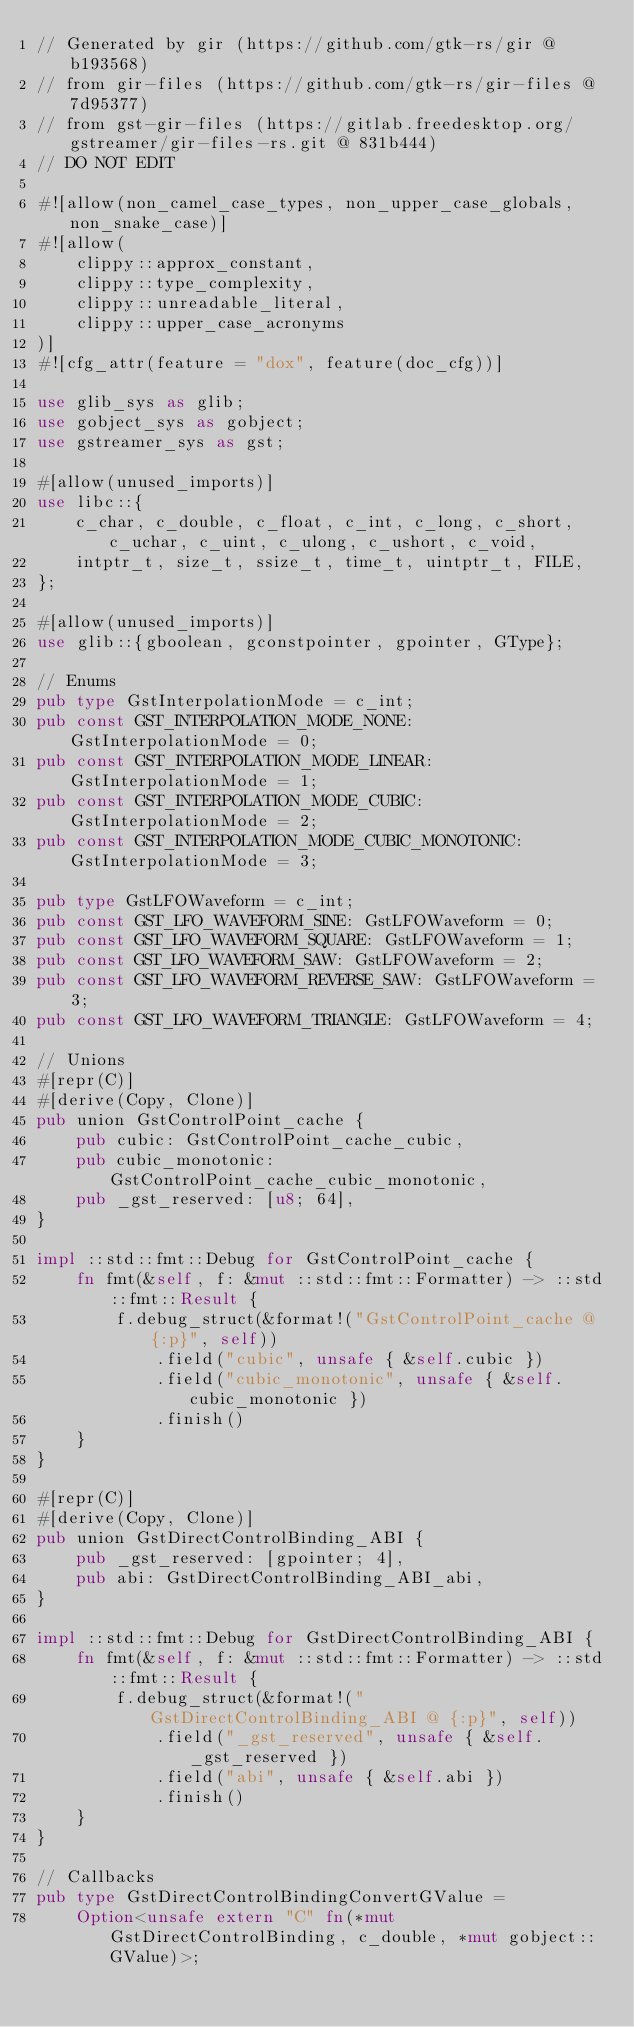<code> <loc_0><loc_0><loc_500><loc_500><_Rust_>// Generated by gir (https://github.com/gtk-rs/gir @ b193568)
// from gir-files (https://github.com/gtk-rs/gir-files @ 7d95377)
// from gst-gir-files (https://gitlab.freedesktop.org/gstreamer/gir-files-rs.git @ 831b444)
// DO NOT EDIT

#![allow(non_camel_case_types, non_upper_case_globals, non_snake_case)]
#![allow(
    clippy::approx_constant,
    clippy::type_complexity,
    clippy::unreadable_literal,
    clippy::upper_case_acronyms
)]
#![cfg_attr(feature = "dox", feature(doc_cfg))]

use glib_sys as glib;
use gobject_sys as gobject;
use gstreamer_sys as gst;

#[allow(unused_imports)]
use libc::{
    c_char, c_double, c_float, c_int, c_long, c_short, c_uchar, c_uint, c_ulong, c_ushort, c_void,
    intptr_t, size_t, ssize_t, time_t, uintptr_t, FILE,
};

#[allow(unused_imports)]
use glib::{gboolean, gconstpointer, gpointer, GType};

// Enums
pub type GstInterpolationMode = c_int;
pub const GST_INTERPOLATION_MODE_NONE: GstInterpolationMode = 0;
pub const GST_INTERPOLATION_MODE_LINEAR: GstInterpolationMode = 1;
pub const GST_INTERPOLATION_MODE_CUBIC: GstInterpolationMode = 2;
pub const GST_INTERPOLATION_MODE_CUBIC_MONOTONIC: GstInterpolationMode = 3;

pub type GstLFOWaveform = c_int;
pub const GST_LFO_WAVEFORM_SINE: GstLFOWaveform = 0;
pub const GST_LFO_WAVEFORM_SQUARE: GstLFOWaveform = 1;
pub const GST_LFO_WAVEFORM_SAW: GstLFOWaveform = 2;
pub const GST_LFO_WAVEFORM_REVERSE_SAW: GstLFOWaveform = 3;
pub const GST_LFO_WAVEFORM_TRIANGLE: GstLFOWaveform = 4;

// Unions
#[repr(C)]
#[derive(Copy, Clone)]
pub union GstControlPoint_cache {
    pub cubic: GstControlPoint_cache_cubic,
    pub cubic_monotonic: GstControlPoint_cache_cubic_monotonic,
    pub _gst_reserved: [u8; 64],
}

impl ::std::fmt::Debug for GstControlPoint_cache {
    fn fmt(&self, f: &mut ::std::fmt::Formatter) -> ::std::fmt::Result {
        f.debug_struct(&format!("GstControlPoint_cache @ {:p}", self))
            .field("cubic", unsafe { &self.cubic })
            .field("cubic_monotonic", unsafe { &self.cubic_monotonic })
            .finish()
    }
}

#[repr(C)]
#[derive(Copy, Clone)]
pub union GstDirectControlBinding_ABI {
    pub _gst_reserved: [gpointer; 4],
    pub abi: GstDirectControlBinding_ABI_abi,
}

impl ::std::fmt::Debug for GstDirectControlBinding_ABI {
    fn fmt(&self, f: &mut ::std::fmt::Formatter) -> ::std::fmt::Result {
        f.debug_struct(&format!("GstDirectControlBinding_ABI @ {:p}", self))
            .field("_gst_reserved", unsafe { &self._gst_reserved })
            .field("abi", unsafe { &self.abi })
            .finish()
    }
}

// Callbacks
pub type GstDirectControlBindingConvertGValue =
    Option<unsafe extern "C" fn(*mut GstDirectControlBinding, c_double, *mut gobject::GValue)>;</code> 